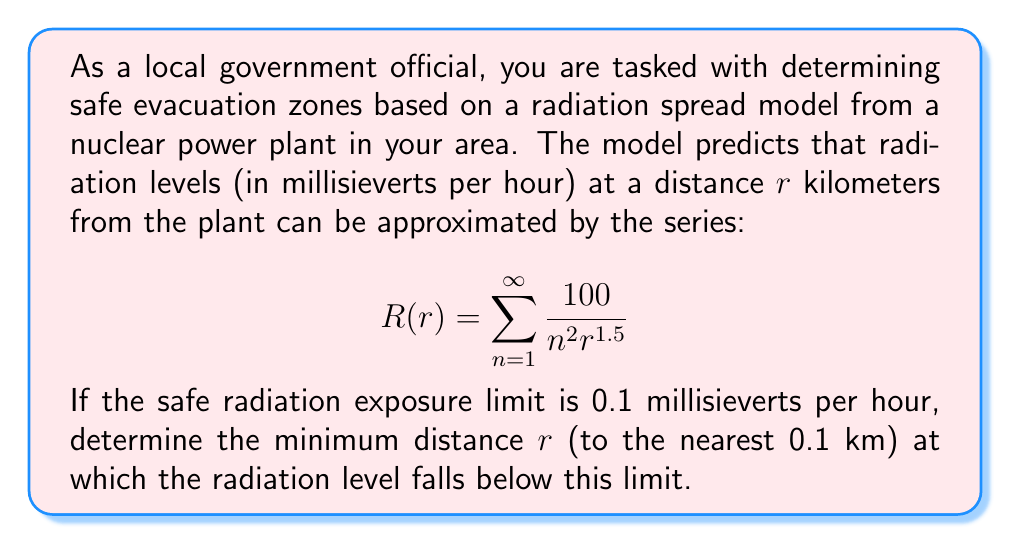Solve this math problem. To solve this problem, we need to follow these steps:

1) First, we need to recognize that this is a p-series with $p = 2$. The sum of this series is known:

   $$\sum_{n=1}^{\infty} \frac{1}{n^2} = \frac{\pi^2}{6}$$

2) We can factor out the terms not dependent on $n$:

   $$R(r) = \frac{100}{r^{1.5}} \sum_{n=1}^{\infty} \frac{1}{n^2} = \frac{100}{r^{1.5}} \cdot \frac{\pi^2}{6}$$

3) Now we set this equal to the safe limit and solve for $r$:

   $$\frac{100}{r^{1.5}} \cdot \frac{\pi^2}{6} = 0.1$$

4) Multiply both sides by $r^{1.5}$:

   $$100 \cdot \frac{\pi^2}{6} = 0.1r^{1.5}$$

5) Divide both sides by 0.1:

   $$1000 \cdot \frac{\pi^2}{6} = r^{1.5}$$

6) Take both sides to the power of $\frac{2}{3}$:

   $$\left(1000 \cdot \frac{\pi^2}{6}\right)^{\frac{2}{3}} = r$$

7) Calculate this value:

   $$r \approx 21.5453 \text{ km}$$

8) Rounding to the nearest 0.1 km:

   $$r \approx 21.5 \text{ km}$$

Therefore, the minimum safe distance is approximately 21.5 km from the nuclear power plant.
Answer: 21.5 km 